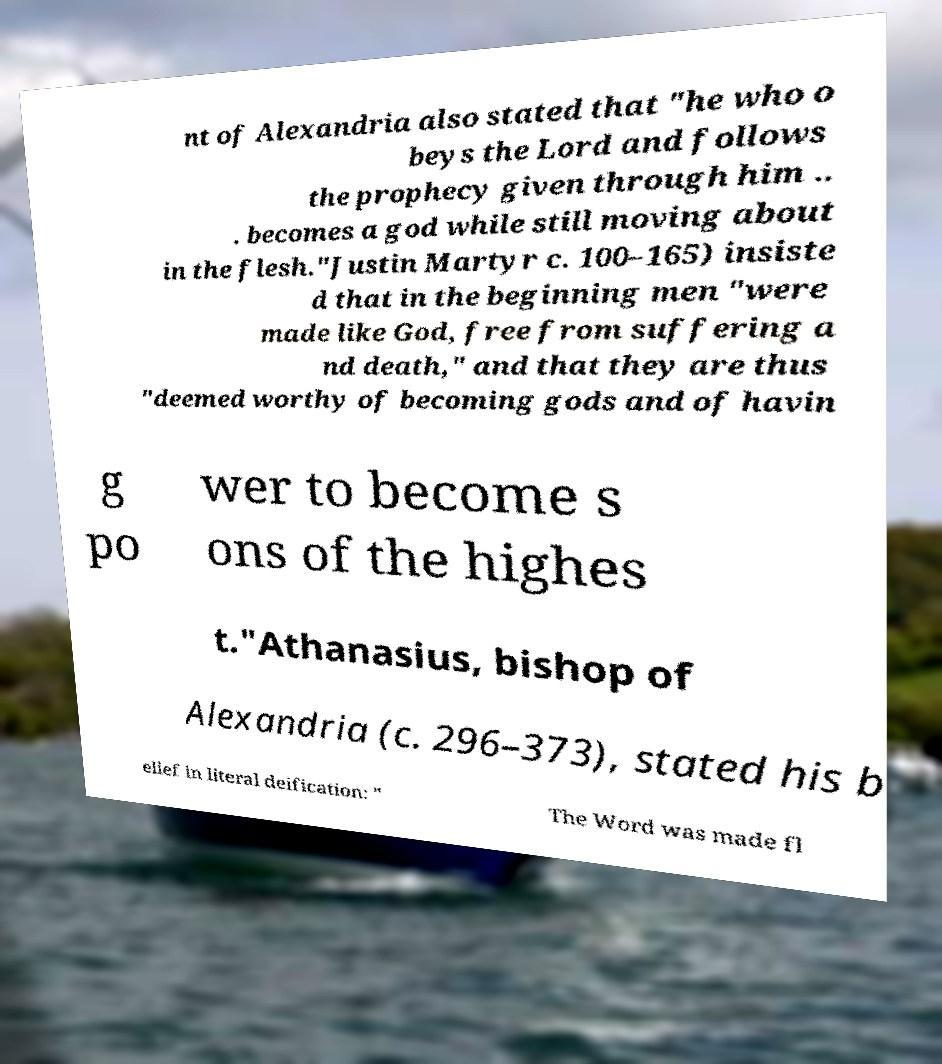Can you read and provide the text displayed in the image?This photo seems to have some interesting text. Can you extract and type it out for me? nt of Alexandria also stated that "he who o beys the Lord and follows the prophecy given through him .. . becomes a god while still moving about in the flesh."Justin Martyr c. 100–165) insiste d that in the beginning men "were made like God, free from suffering a nd death," and that they are thus "deemed worthy of becoming gods and of havin g po wer to become s ons of the highes t."Athanasius, bishop of Alexandria (c. 296–373), stated his b elief in literal deification: " The Word was made fl 